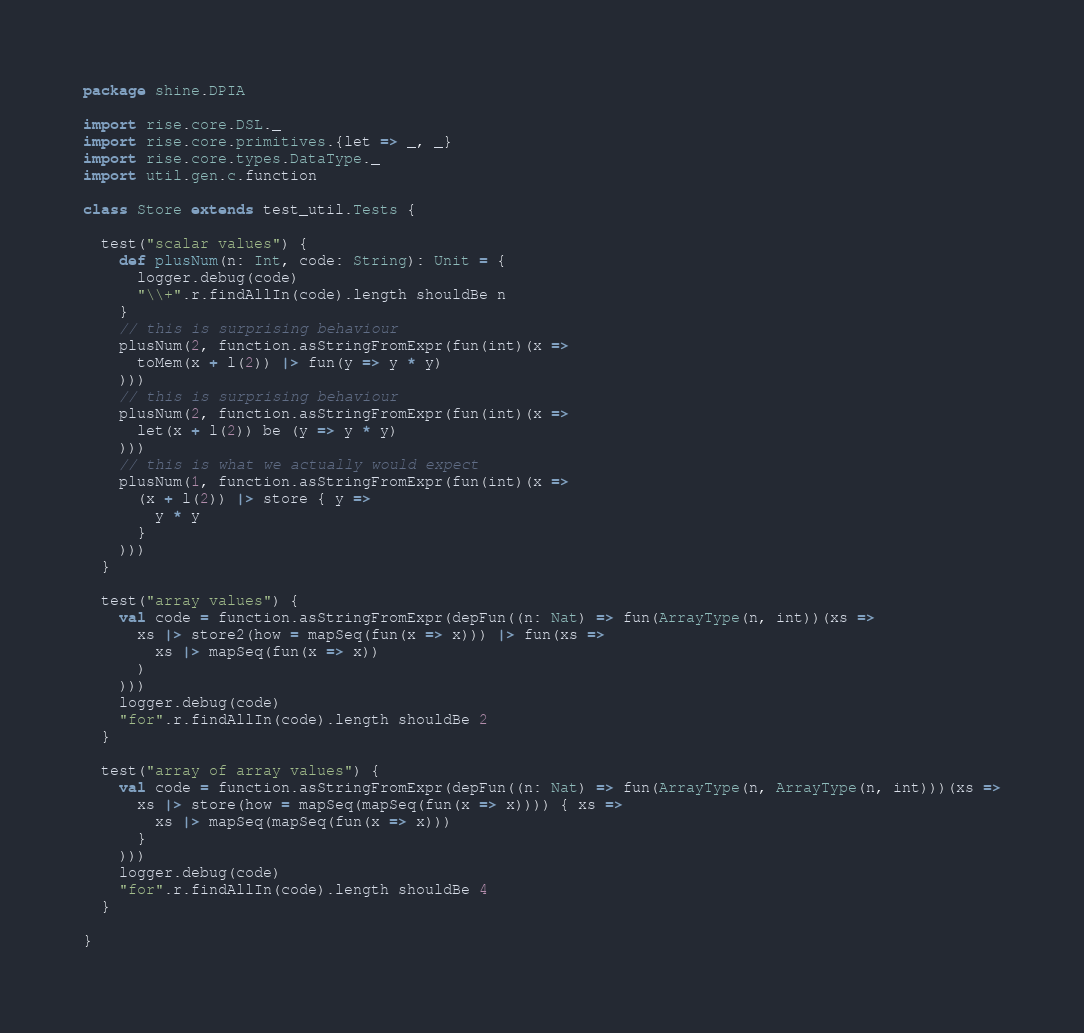Convert code to text. <code><loc_0><loc_0><loc_500><loc_500><_Scala_>package shine.DPIA

import rise.core.DSL._
import rise.core.primitives.{let => _, _}
import rise.core.types.DataType._
import util.gen.c.function

class Store extends test_util.Tests {

  test("scalar values") {
    def plusNum(n: Int, code: String): Unit = {
      logger.debug(code)
      "\\+".r.findAllIn(code).length shouldBe n
    }
    // this is surprising behaviour
    plusNum(2, function.asStringFromExpr(fun(int)(x =>
      toMem(x + l(2)) |> fun(y => y * y)
    )))
    // this is surprising behaviour
    plusNum(2, function.asStringFromExpr(fun(int)(x =>
      let(x + l(2)) be (y => y * y)
    )))
    // this is what we actually would expect
    plusNum(1, function.asStringFromExpr(fun(int)(x =>
      (x + l(2)) |> store { y =>
        y * y
      }
    )))
  }

  test("array values") {
    val code = function.asStringFromExpr(depFun((n: Nat) => fun(ArrayType(n, int))(xs =>
      xs |> store2(how = mapSeq(fun(x => x))) |> fun(xs =>
        xs |> mapSeq(fun(x => x))
      )
    )))
    logger.debug(code)
    "for".r.findAllIn(code).length shouldBe 2
  }

  test("array of array values") {
    val code = function.asStringFromExpr(depFun((n: Nat) => fun(ArrayType(n, ArrayType(n, int)))(xs =>
      xs |> store(how = mapSeq(mapSeq(fun(x => x)))) { xs =>
        xs |> mapSeq(mapSeq(fun(x => x)))
      }
    )))
    logger.debug(code)
    "for".r.findAllIn(code).length shouldBe 4
  }

}
</code> 